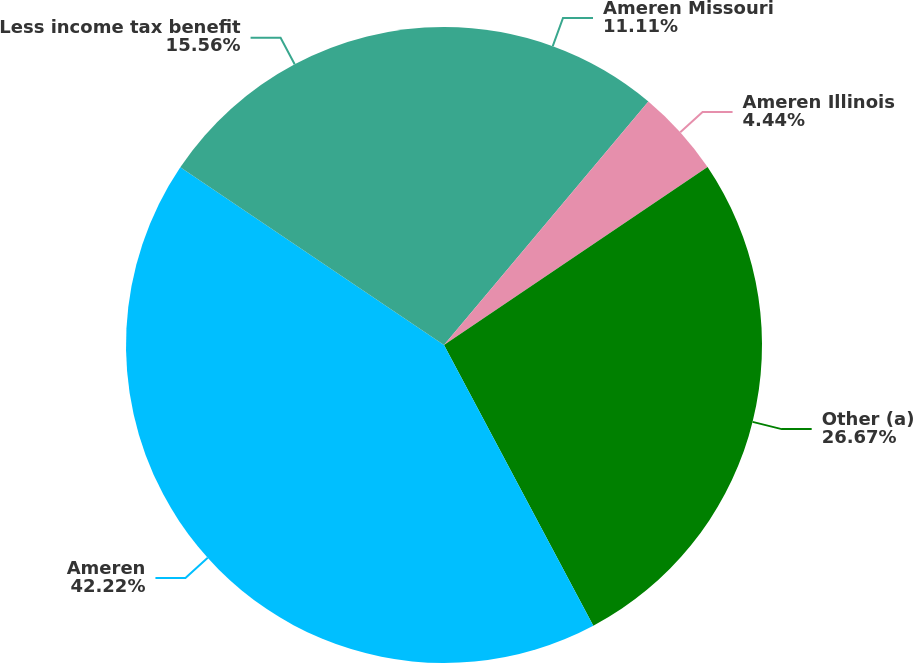Convert chart. <chart><loc_0><loc_0><loc_500><loc_500><pie_chart><fcel>Ameren Missouri<fcel>Ameren Illinois<fcel>Other (a)<fcel>Ameren<fcel>Less income tax benefit<nl><fcel>11.11%<fcel>4.44%<fcel>26.67%<fcel>42.22%<fcel>15.56%<nl></chart> 